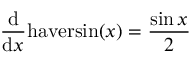Convert formula to latex. <formula><loc_0><loc_0><loc_500><loc_500>{ \frac { d } { d x } } h a v e r \sin ( x ) = { \frac { \sin { x } } { 2 } }</formula> 